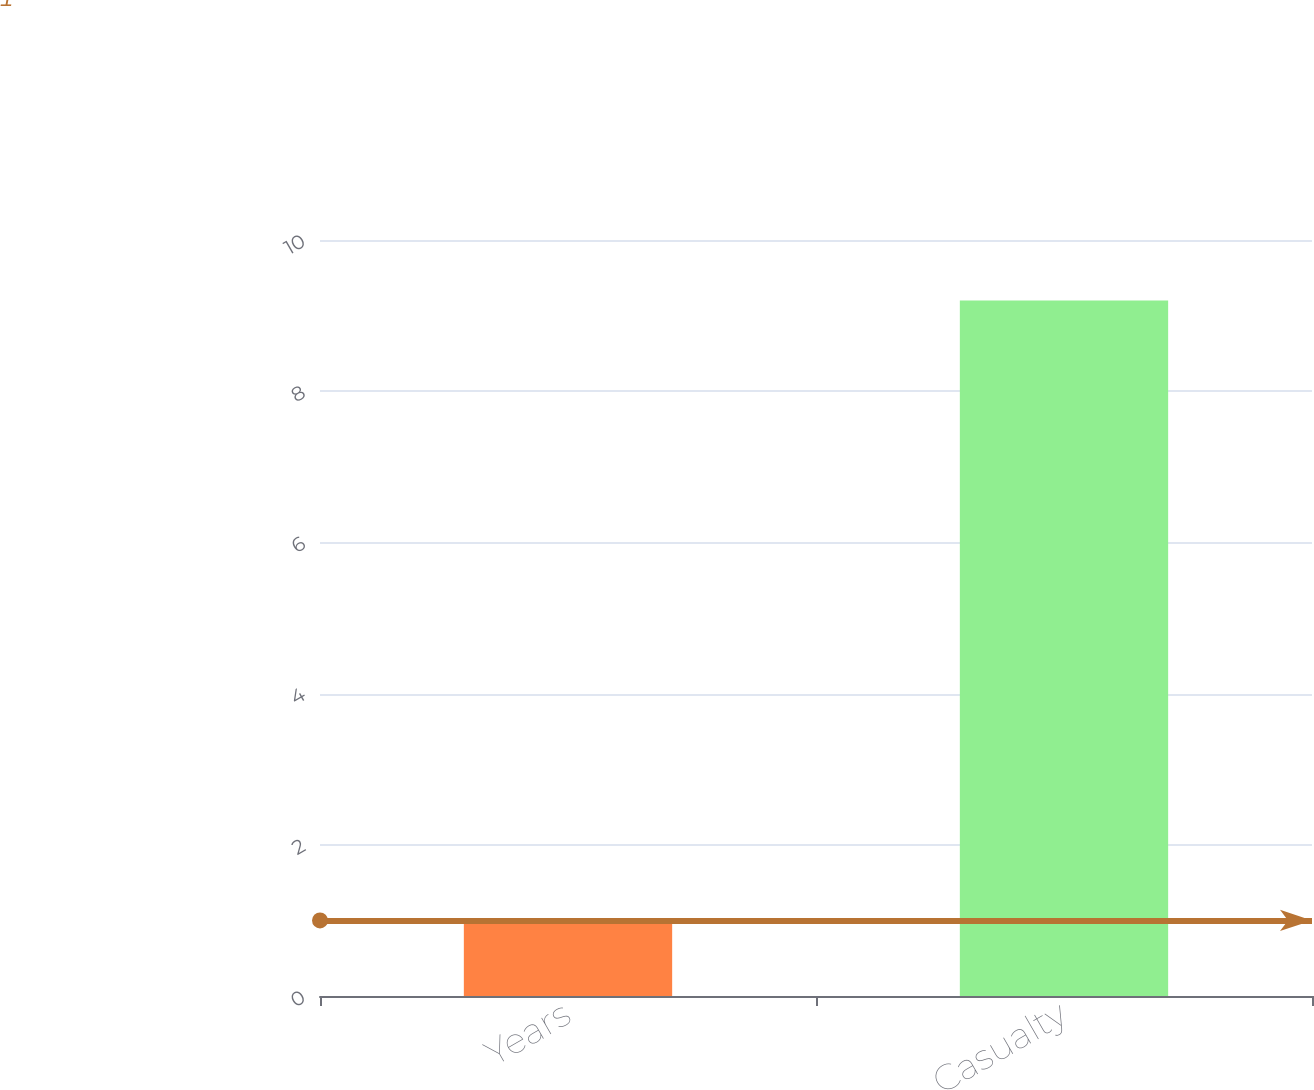Convert chart. <chart><loc_0><loc_0><loc_500><loc_500><bar_chart><fcel>Years<fcel>Casualty<nl><fcel>1<fcel>9.2<nl></chart> 